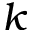<formula> <loc_0><loc_0><loc_500><loc_500>k</formula> 